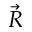<formula> <loc_0><loc_0><loc_500><loc_500>\vec { R }</formula> 